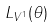Convert formula to latex. <formula><loc_0><loc_0><loc_500><loc_500>L _ { V ^ { 1 } } ( \theta )</formula> 